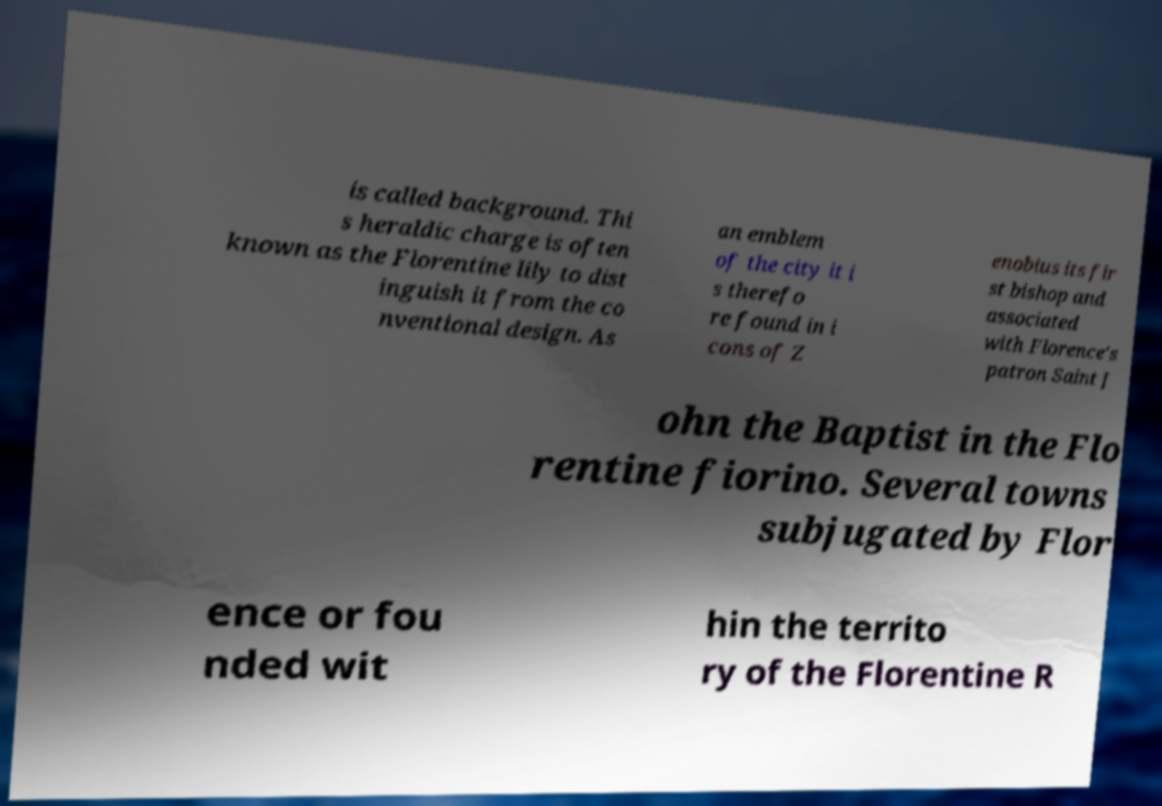There's text embedded in this image that I need extracted. Can you transcribe it verbatim? is called background. Thi s heraldic charge is often known as the Florentine lily to dist inguish it from the co nventional design. As an emblem of the city it i s therefo re found in i cons of Z enobius its fir st bishop and associated with Florence's patron Saint J ohn the Baptist in the Flo rentine fiorino. Several towns subjugated by Flor ence or fou nded wit hin the territo ry of the Florentine R 